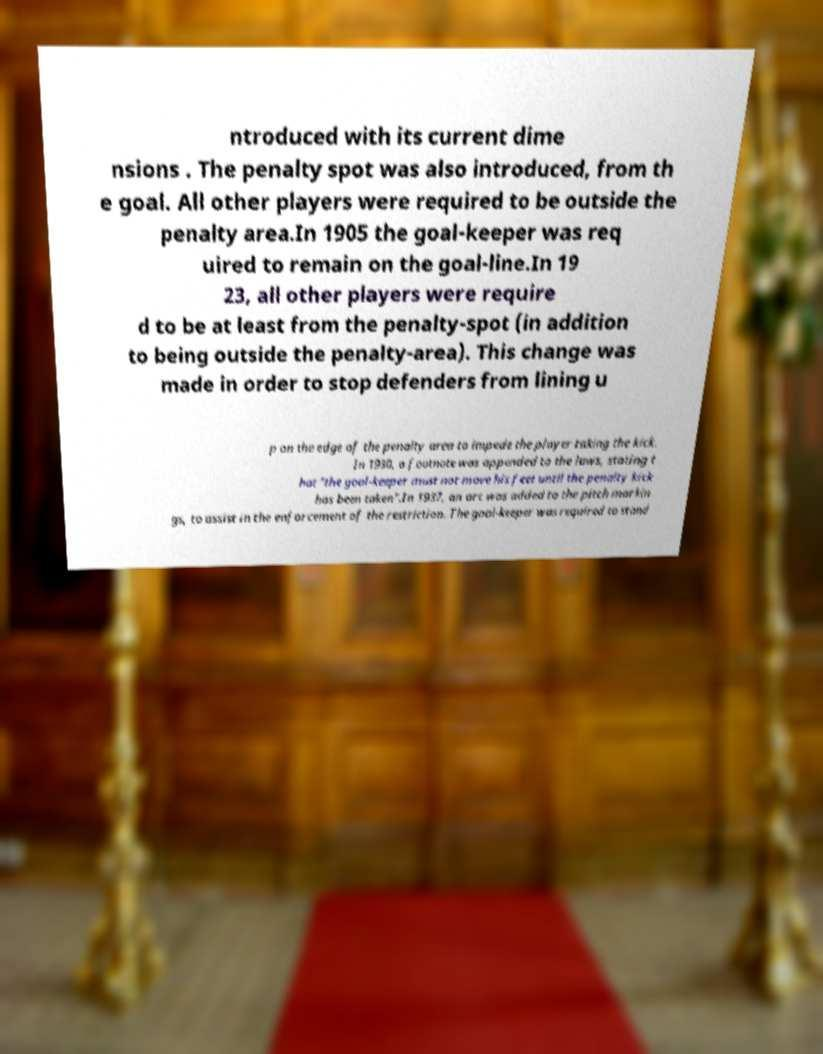Please identify and transcribe the text found in this image. ntroduced with its current dime nsions . The penalty spot was also introduced, from th e goal. All other players were required to be outside the penalty area.In 1905 the goal-keeper was req uired to remain on the goal-line.In 19 23, all other players were require d to be at least from the penalty-spot (in addition to being outside the penalty-area). This change was made in order to stop defenders from lining u p on the edge of the penalty area to impede the player taking the kick. In 1930, a footnote was appended to the laws, stating t hat "the goal-keeper must not move his feet until the penalty kick has been taken".In 1937, an arc was added to the pitch markin gs, to assist in the enforcement of the restriction. The goal-keeper was required to stand 